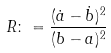Convert formula to latex. <formula><loc_0><loc_0><loc_500><loc_500>R \colon = \frac { ( \dot { a } - \dot { b } ) ^ { 2 } } { ( b - a ) ^ { 2 } }</formula> 